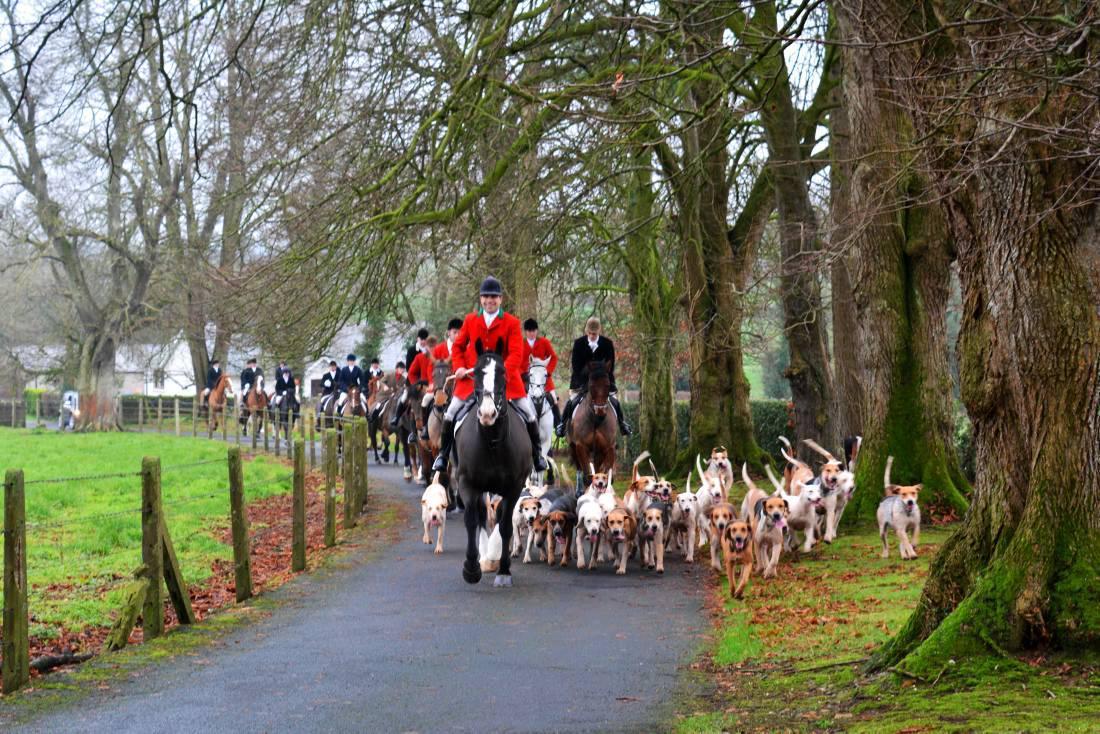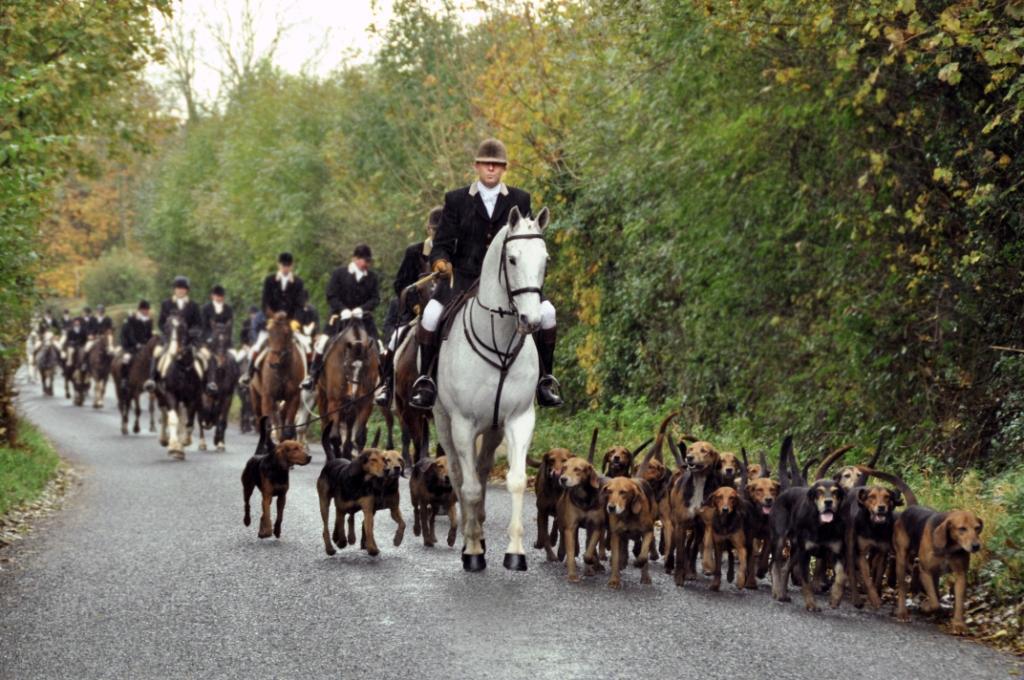The first image is the image on the left, the second image is the image on the right. Given the left and right images, does the statement "An image contains a large herd of dogs following a man on a horse that is wearing a red jacket." hold true? Answer yes or no. Yes. The first image is the image on the left, the second image is the image on the right. Examine the images to the left and right. Is the description "There are dogs and horses." accurate? Answer yes or no. Yes. 